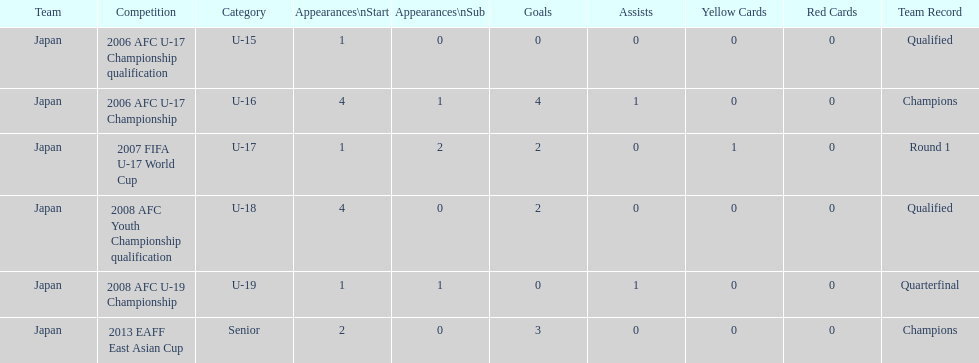Which competition had the highest number of starts and goals? 2006 AFC U-17 Championship. 